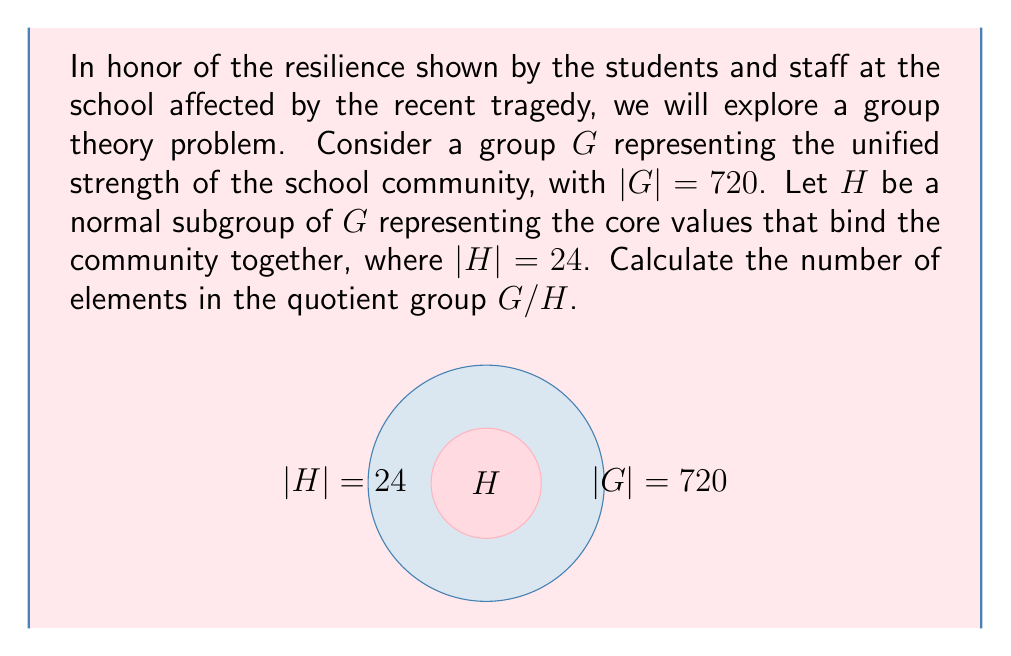Can you answer this question? To solve this problem, we'll follow these steps:

1) Recall the Lagrange's Theorem: For a finite group $G$ and its subgroup $H$, we have:

   $$|G| = |H| \cdot [G:H]$$

   where $[G:H]$ is the index of $H$ in $G$, which is equal to the number of elements in the quotient group $G/H$.

2) We are given:
   $|G| = 720$
   $|H| = 24$

3) Substituting these values into Lagrange's Theorem:

   $$720 = 24 \cdot [G:H]$$

4) Solving for $[G:H]$:

   $$[G:H] = \frac{720}{24} = 30$$

5) Therefore, the number of elements in the quotient group $G/H$ is 30.

This result symbolizes how the 30 distinct cosets of $H$ in $G$ represent the various ways the school community comes together while maintaining their core values.
Answer: 30 